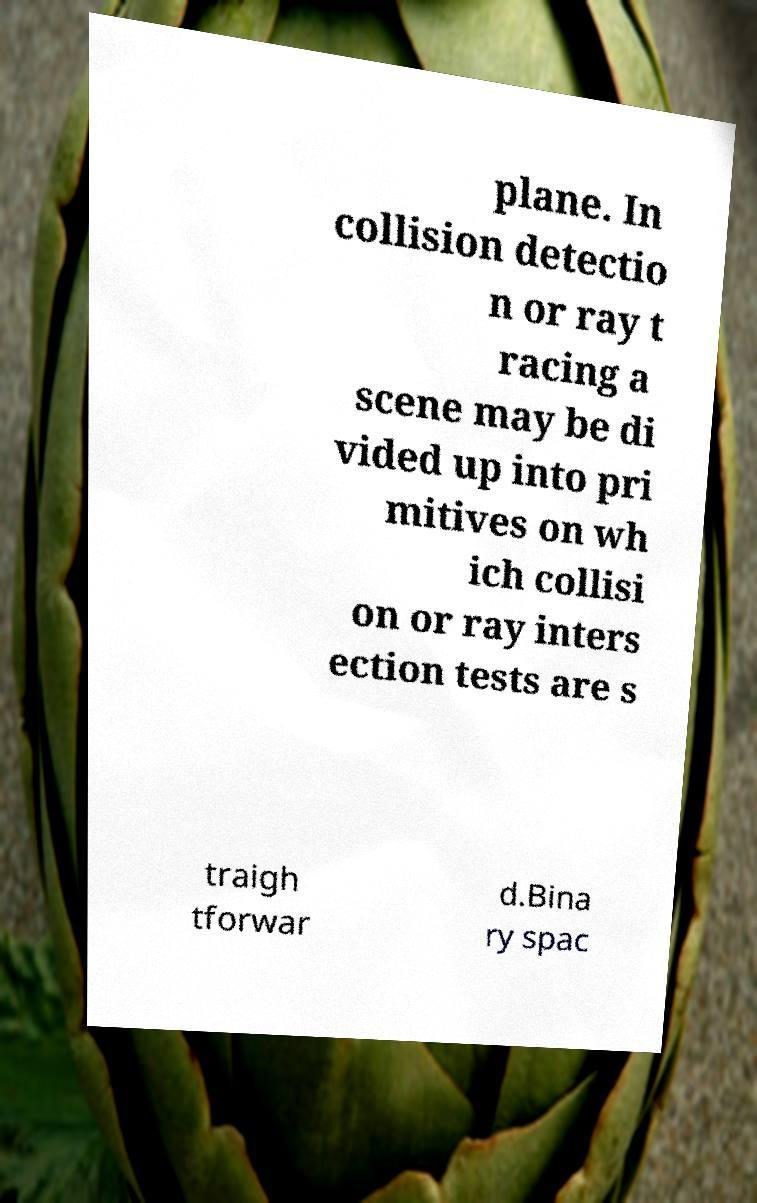There's text embedded in this image that I need extracted. Can you transcribe it verbatim? plane. In collision detectio n or ray t racing a scene may be di vided up into pri mitives on wh ich collisi on or ray inters ection tests are s traigh tforwar d.Bina ry spac 